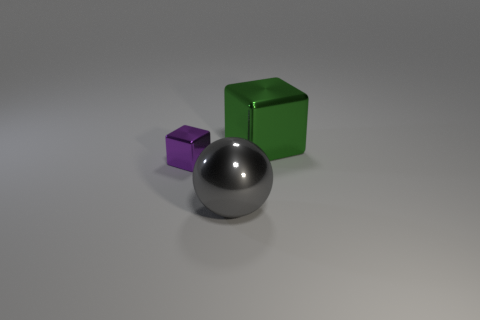How big is the metal object to the left of the large shiny thing in front of the green block?
Provide a short and direct response. Small. There is a shiny object that is on the left side of the green shiny block and right of the small purple cube; what color is it?
Give a very brief answer. Gray. Is the large green object made of the same material as the small purple block?
Offer a terse response. Yes. What number of small things are purple metal objects or gray balls?
Your answer should be compact. 1. Are there any other things that are the same shape as the gray object?
Provide a short and direct response. No. Is there any other thing that is the same size as the purple object?
Your answer should be compact. No. The large cube that is the same material as the gray thing is what color?
Ensure brevity in your answer.  Green. There is a object that is to the left of the big ball; what color is it?
Provide a succinct answer. Purple. Is the number of green cubes in front of the large green metallic block less than the number of large cubes behind the purple metal object?
Your response must be concise. Yes. There is a gray shiny thing; how many big balls are in front of it?
Your answer should be very brief. 0. 